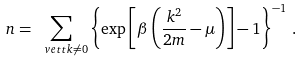<formula> <loc_0><loc_0><loc_500><loc_500>n = \sum _ { \ v e t t k \neq 0 } \left \{ \exp \left [ \beta \left ( \frac { k ^ { 2 } } { 2 m } - \mu \right ) \right ] - 1 \right \} ^ { - 1 } \, .</formula> 